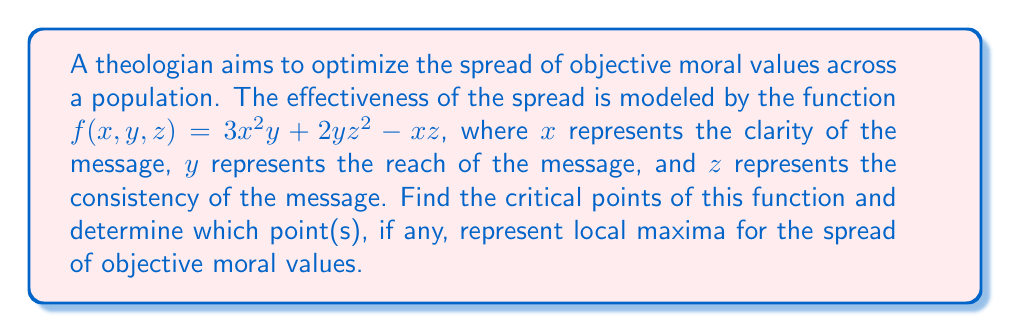Can you solve this math problem? To find the critical points, we need to follow these steps:

1) Calculate the partial derivatives of $f$ with respect to $x$, $y$, and $z$:

   $\frac{\partial f}{\partial x} = 6xy - z$
   $\frac{\partial f}{\partial y} = 3x^2 + 2z^2$
   $\frac{\partial f}{\partial z} = 4yz - x$

2) Set each partial derivative to zero and solve the system of equations:

   $6xy - z = 0$ ... (1)
   $3x^2 + 2z^2 = 0$ ... (2)
   $4yz - x = 0$ ... (3)

3) From equation (2), since $x^2$ and $z^2$ are non-negative, the only solution is $x = z = 0$.

4) Substituting these into equation (1):

   $6(0)(y) - 0 = 0$

   This is true for any value of $y$.

5) Substituting into equation (3):

   $4y(0) - 0 = 0$

   This is also true for any value of $y$.

6) Therefore, the critical points are of the form $(0, y, 0)$ for any real number $y$.

7) To determine if these are local maxima, we need to use the second derivative test. Calculate the second partial derivatives:

   $\frac{\partial^2 f}{\partial x^2} = 0$
   $\frac{\partial^2 f}{\partial y^2} = 0$
   $\frac{\partial^2 f}{\partial z^2} = 4y$
   $\frac{\partial^2 f}{\partial x\partial y} = \frac{\partial^2 f}{\partial y\partial x} = 6x$
   $\frac{\partial^2 f}{\partial x\partial z} = \frac{\partial^2 f}{\partial z\partial x} = -1$
   $\frac{\partial^2 f}{\partial y\partial z} = \frac{\partial^2 f}{\partial z\partial y} = 4z$

8) The Hessian matrix at the critical points $(0, y, 0)$ is:

   $$H = \begin{bmatrix} 
   0 & 0 & -1 \\
   0 & 0 & 0 \\
   -1 & 0 & 4y
   \end{bmatrix}$$

9) The determinant of this matrix is 0, so the second derivative test is inconclusive.

10) Examining the function near these points reveals that they are actually saddle points, not local maxima.
Answer: Critical points: $(0, y, 0)$ for all real $y$. No local maxima exist. 